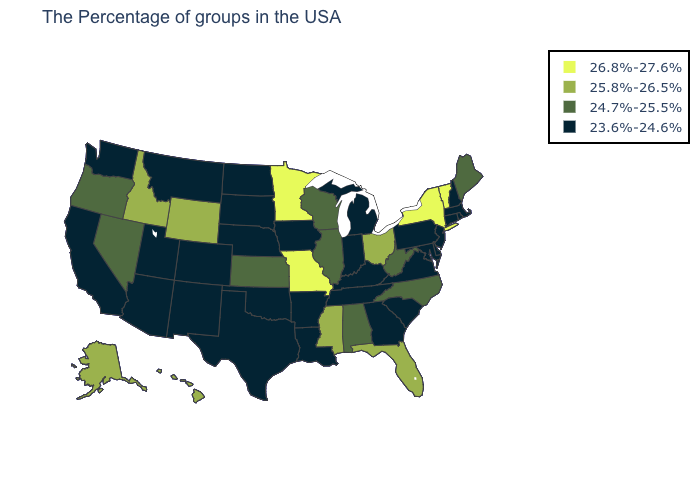What is the value of Missouri?
Write a very short answer. 26.8%-27.6%. What is the highest value in the USA?
Short answer required. 26.8%-27.6%. Is the legend a continuous bar?
Short answer required. No. Which states have the lowest value in the South?
Short answer required. Delaware, Maryland, Virginia, South Carolina, Georgia, Kentucky, Tennessee, Louisiana, Arkansas, Oklahoma, Texas. Among the states that border Kentucky , which have the highest value?
Concise answer only. Missouri. What is the value of Wisconsin?
Keep it brief. 24.7%-25.5%. Name the states that have a value in the range 23.6%-24.6%?
Short answer required. Massachusetts, Rhode Island, New Hampshire, Connecticut, New Jersey, Delaware, Maryland, Pennsylvania, Virginia, South Carolina, Georgia, Michigan, Kentucky, Indiana, Tennessee, Louisiana, Arkansas, Iowa, Nebraska, Oklahoma, Texas, South Dakota, North Dakota, Colorado, New Mexico, Utah, Montana, Arizona, California, Washington. Which states have the lowest value in the USA?
Give a very brief answer. Massachusetts, Rhode Island, New Hampshire, Connecticut, New Jersey, Delaware, Maryland, Pennsylvania, Virginia, South Carolina, Georgia, Michigan, Kentucky, Indiana, Tennessee, Louisiana, Arkansas, Iowa, Nebraska, Oklahoma, Texas, South Dakota, North Dakota, Colorado, New Mexico, Utah, Montana, Arizona, California, Washington. Does Washington have the same value as New Mexico?
Concise answer only. Yes. Name the states that have a value in the range 25.8%-26.5%?
Write a very short answer. Ohio, Florida, Mississippi, Wyoming, Idaho, Alaska, Hawaii. What is the value of Arkansas?
Short answer required. 23.6%-24.6%. Among the states that border California , does Oregon have the lowest value?
Give a very brief answer. No. Does the first symbol in the legend represent the smallest category?
Concise answer only. No. Does the first symbol in the legend represent the smallest category?
Answer briefly. No. Name the states that have a value in the range 25.8%-26.5%?
Write a very short answer. Ohio, Florida, Mississippi, Wyoming, Idaho, Alaska, Hawaii. 